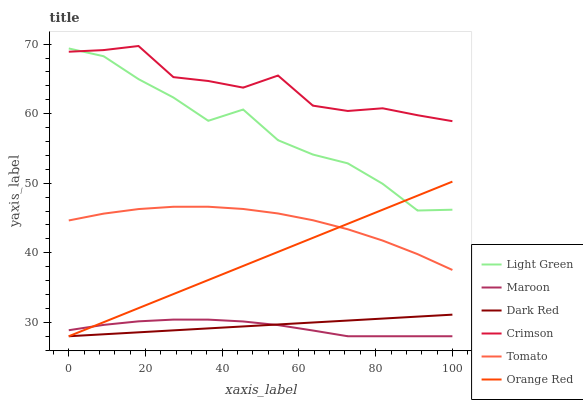Does Dark Red have the minimum area under the curve?
Answer yes or no. No. Does Dark Red have the maximum area under the curve?
Answer yes or no. No. Is Maroon the smoothest?
Answer yes or no. No. Is Maroon the roughest?
Answer yes or no. No. Does Light Green have the lowest value?
Answer yes or no. No. Does Dark Red have the highest value?
Answer yes or no. No. Is Tomato less than Light Green?
Answer yes or no. Yes. Is Tomato greater than Maroon?
Answer yes or no. Yes. Does Tomato intersect Light Green?
Answer yes or no. No. 